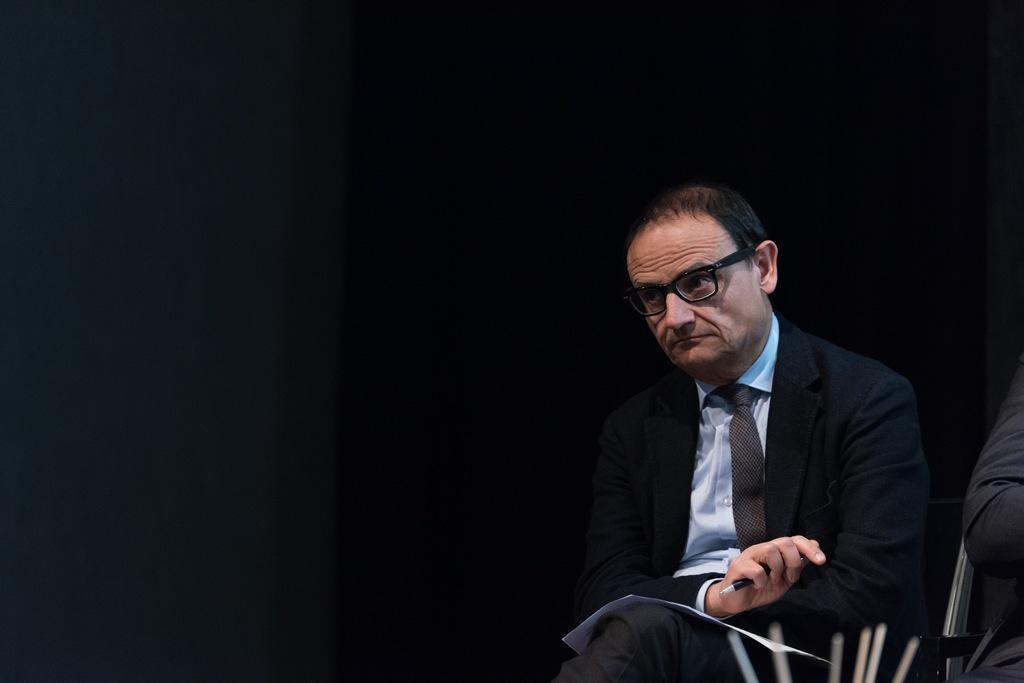Please provide a concise description of this image. In this picture I can observe a man sitting on the chair on the right side. He is wearing spectacles and a coat. The background is dark. 